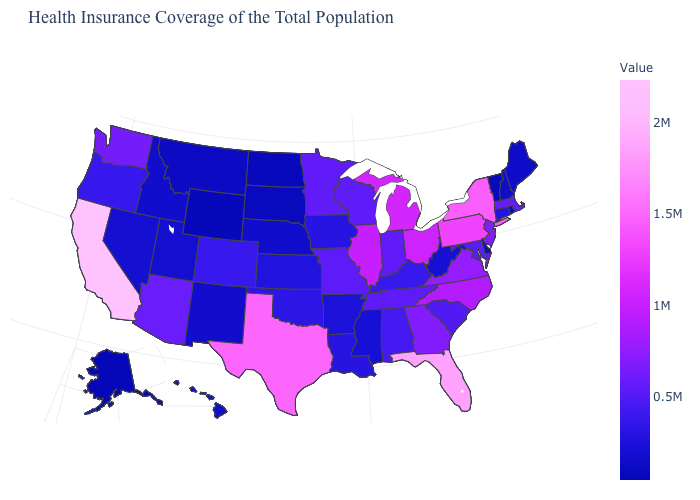Does Wyoming have a higher value than California?
Short answer required. No. Does Virginia have the highest value in the USA?
Give a very brief answer. No. 